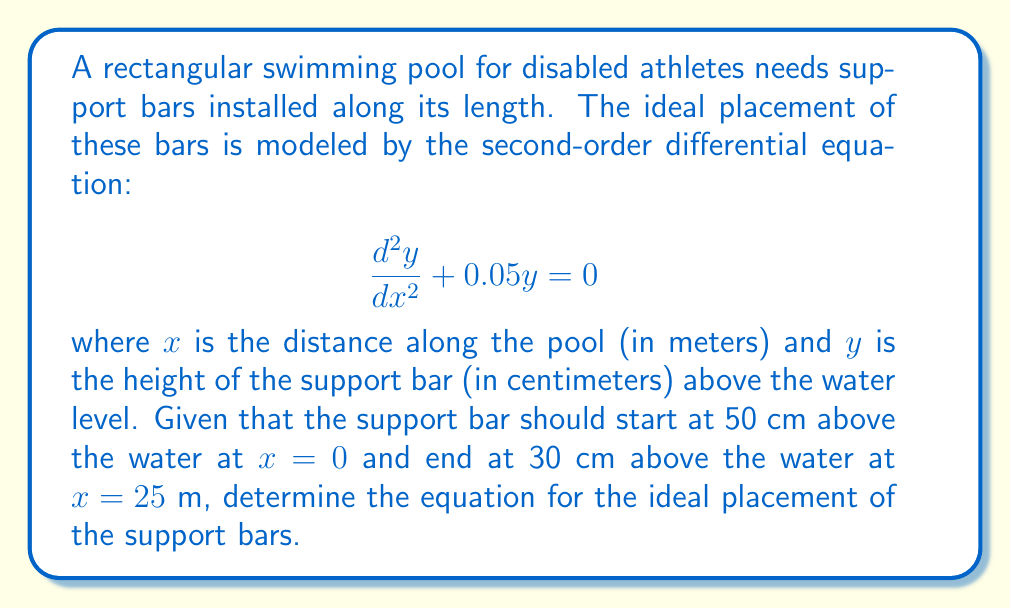Provide a solution to this math problem. To solve this problem, we'll follow these steps:

1) The general solution for the given differential equation is:
   $$y = A\cos(kx) + B\sin(kx)$$
   where $k^2 = 0.05$, so $k = \sqrt{0.05} \approx 0.2236$

2) We have two boundary conditions:
   At $x=0$, $y=50$ cm
   At $x=25$ m, $y=30$ cm

3) Using the first condition ($x=0$, $y=50$):
   $$50 = A\cos(0) + B\sin(0) = A$$

4) Using the second condition ($x=25$, $y=30$):
   $$30 = 50\cos(0.2236 * 25) + B\sin(0.2236 * 25)$$

5) Simplify:
   $$30 = 50\cos(5.59) + B\sin(5.59)$$
   $$30 = 50(-0.7071) + B(0.7071)$$
   $$30 = -35.355 + 0.7071B$$

6) Solve for B:
   $$0.7071B = 65.355$$
   $$B = 92.43$$

7) Therefore, the equation for the ideal placement of support bars is:
   $$y = 50\cos(0.2236x) + 92.43\sin(0.2236x)$$
Answer: The equation for the ideal placement of support bars is:
$$y = 50\cos(0.2236x) + 92.43\sin(0.2236x)$$
where $y$ is the height in centimeters and $x$ is the distance along the pool in meters. 